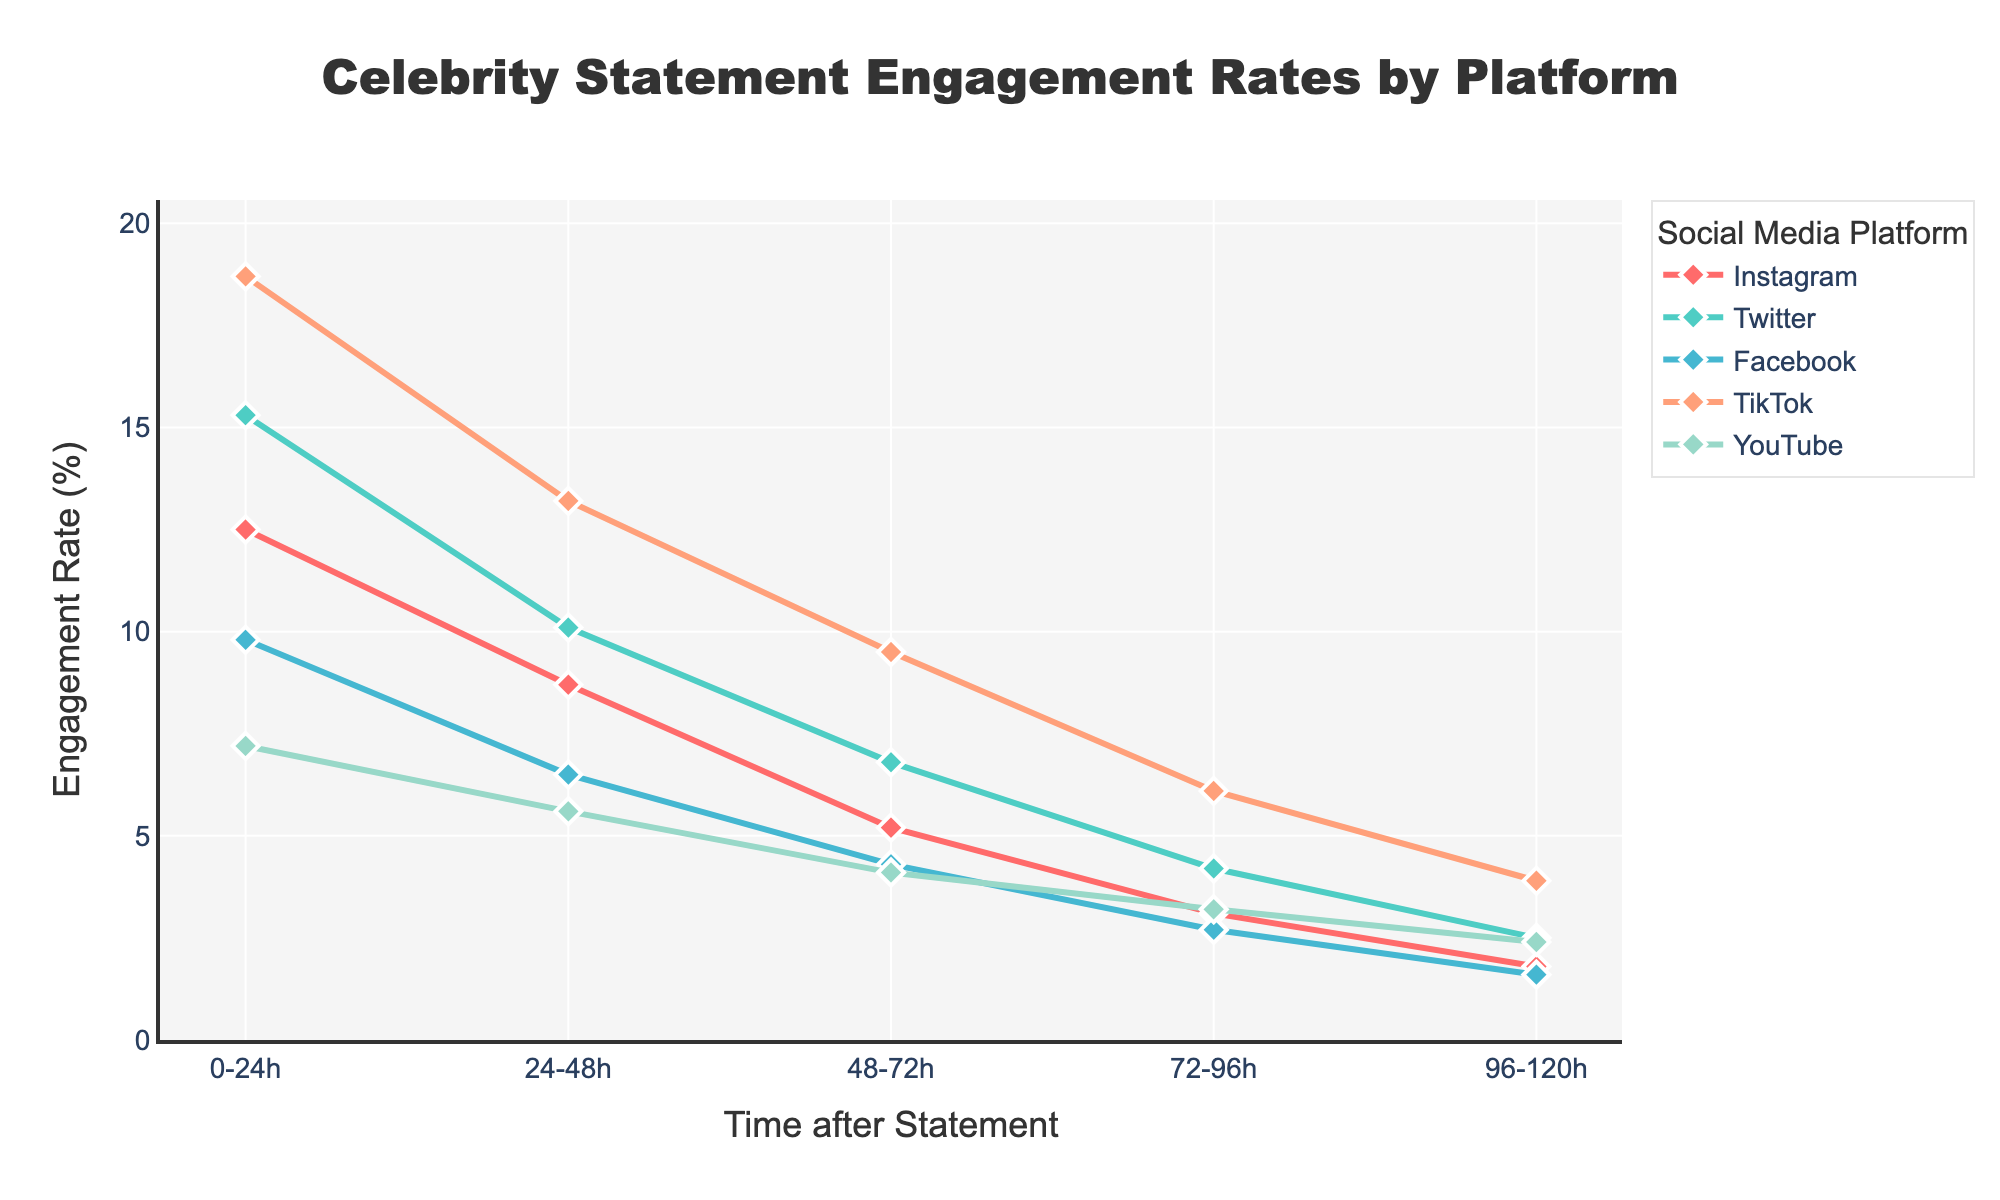What is the trend for engagement rates on TikTok over the 120 hours? To determine the trend for TikTok, observe the engagement rates at different intervals: 0-24h (18.7%), 24-48h (13.2%), 48-72h (9.5%), 72-96h (6.1%), and 96-120h (3.9%). The engagement rate is consistently decreasing over time.
Answer: Decreasing Which platform has the highest engagement rate in the first 24 hours? Look at the engagement rates at 0-24h for each platform: Instagram (12.5%), Twitter (15.3%), Facebook (9.8%), TikTok (18.7%), and YouTube (7.2%). TikTok has the highest engagement rate.
Answer: TikTok How does the engagement rate on Instagram compare to Facebook after 72 hours? After 72-96 hours, Instagram has an engagement rate of 3.1% while Facebook has 2.7%. Thus, Instagram’s engagement rate is slightly higher than Facebook’s.
Answer: Instagram is higher What is the average engagement rate on Twitter over the 120 hours? The engagement rates on Twitter are: 0-24h (15.3%), 24-48h (10.1%), 48-72h (6.8%), 72-96h (4.2%), and 96-120h (2.5%). The average is calculated as: (15.3 + 10.1 + 6.8 + 4.2 + 2.5) / 5 = 7.78%.
Answer: 7.78% Between 24-48 hours and 72-96 hours, which platform shows the greatest decline in engagement rate? The changes in engagement rates between the intervals for each platform are: Instagram (8.7 - 3.1 = 5.6), Twitter (10.1 - 4.2 = 5.9), Facebook (6.5 - 2.7 = 3.8), TikTok (13.2 - 6.1 = 7.1), YouTube (5.6 - 3.2 = 2.4). TikTok shows the greatest decline.
Answer: TikTok What is the sum of engagement rates for YouTube at all intervals? Summing the engagement rates at all intervals for YouTube: 7.2 + 5.6 + 4.1 + 3.2 + 2.4 = 22.5%.
Answer: 22.5% Which platform has the smallest decrease in engagement rate between the first 24 hours and the last 24 hours? Calculate the differences in engagement rates from 0-24h to 96-120h for each platform: Instagram (12.5 - 1.8 = 10.7), Twitter (15.3 - 2.5 = 12.8), Facebook (9.8 - 1.6 = 8.2), TikTok (18.7 - 3.9 = 14.8), YouTube (7.2 - 2.4 = 4.8). YouTube has the smallest decrease.
Answer: YouTube What is the combined engagement rate for Facebook and Instagram at 24-48 hours? Add the engagement rates for Facebook (6.5%) and Instagram (8.7%) at 24-48h: 6.5 + 8.7 = 15.2%.
Answer: 15.2% 